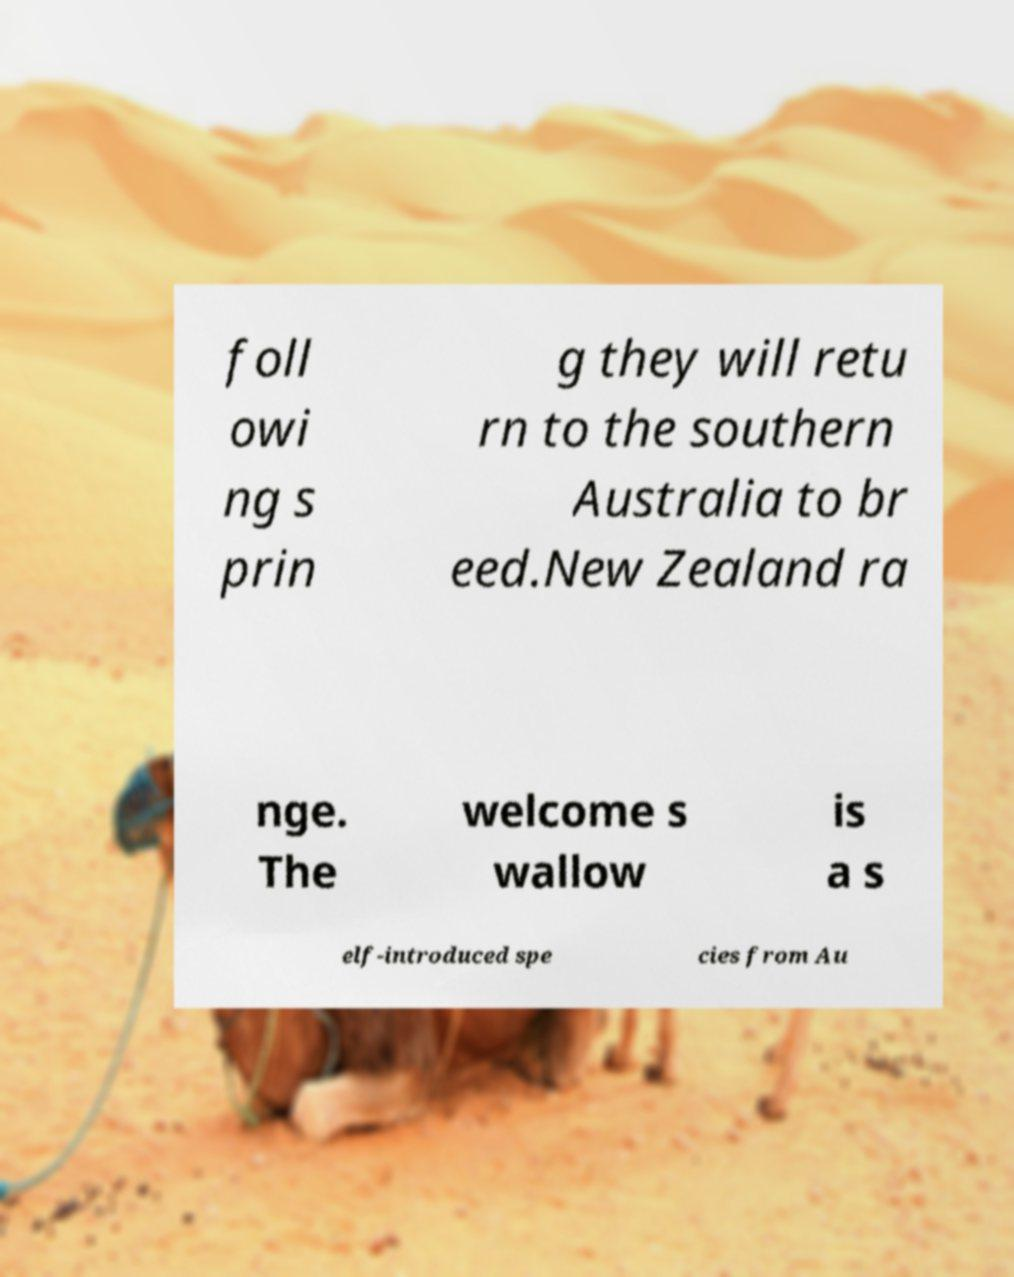Could you assist in decoding the text presented in this image and type it out clearly? foll owi ng s prin g they will retu rn to the southern Australia to br eed.New Zealand ra nge. The welcome s wallow is a s elf-introduced spe cies from Au 